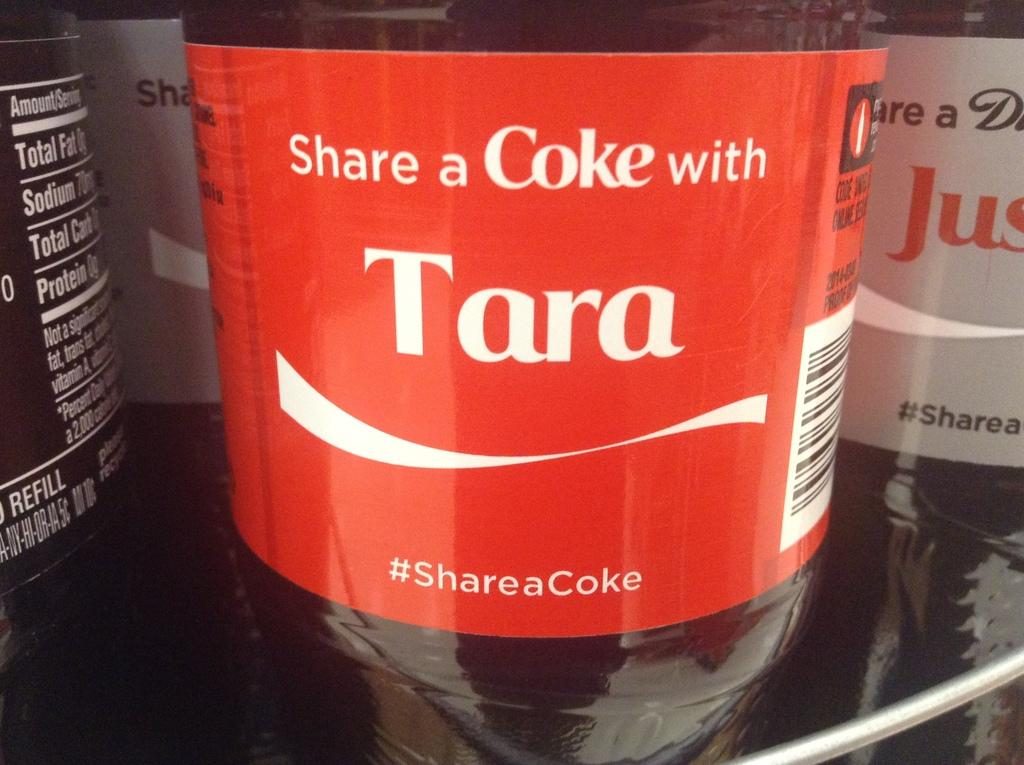<image>
Offer a succinct explanation of the picture presented. A bottle of Coke that says the name Tara. 